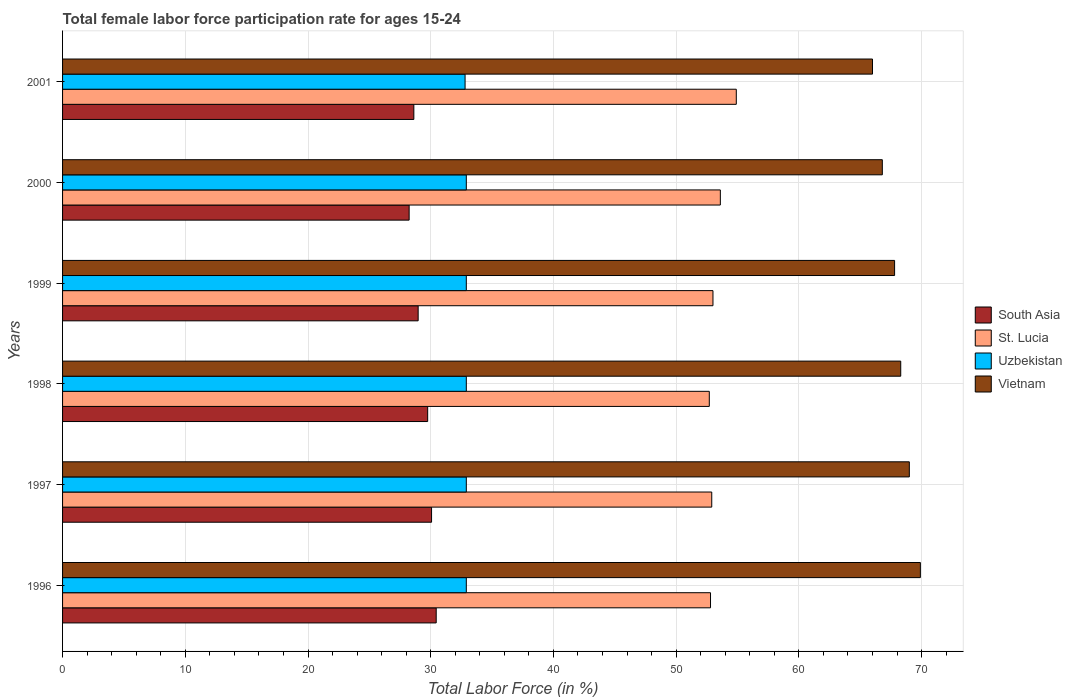How many groups of bars are there?
Provide a short and direct response. 6. How many bars are there on the 6th tick from the top?
Your answer should be compact. 4. What is the female labor force participation rate in South Asia in 1997?
Make the answer very short. 30.07. Across all years, what is the maximum female labor force participation rate in Vietnam?
Make the answer very short. 69.9. Across all years, what is the minimum female labor force participation rate in South Asia?
Your response must be concise. 28.24. In which year was the female labor force participation rate in South Asia maximum?
Make the answer very short. 1996. In which year was the female labor force participation rate in Vietnam minimum?
Your answer should be very brief. 2001. What is the total female labor force participation rate in Vietnam in the graph?
Keep it short and to the point. 407.8. What is the difference between the female labor force participation rate in Vietnam in 1996 and that in 1997?
Your answer should be compact. 0.9. What is the difference between the female labor force participation rate in Vietnam in 2000 and the female labor force participation rate in Uzbekistan in 1997?
Offer a terse response. 33.9. What is the average female labor force participation rate in Uzbekistan per year?
Give a very brief answer. 32.88. In the year 2001, what is the difference between the female labor force participation rate in Uzbekistan and female labor force participation rate in Vietnam?
Your answer should be very brief. -33.2. In how many years, is the female labor force participation rate in Uzbekistan greater than 10 %?
Your answer should be very brief. 6. What is the ratio of the female labor force participation rate in South Asia in 1996 to that in 1998?
Make the answer very short. 1.02. Is the difference between the female labor force participation rate in Uzbekistan in 1998 and 2000 greater than the difference between the female labor force participation rate in Vietnam in 1998 and 2000?
Your answer should be very brief. No. What is the difference between the highest and the second highest female labor force participation rate in South Asia?
Keep it short and to the point. 0.38. What is the difference between the highest and the lowest female labor force participation rate in St. Lucia?
Provide a short and direct response. 2.2. In how many years, is the female labor force participation rate in St. Lucia greater than the average female labor force participation rate in St. Lucia taken over all years?
Your answer should be compact. 2. Is the sum of the female labor force participation rate in Uzbekistan in 1998 and 2001 greater than the maximum female labor force participation rate in St. Lucia across all years?
Provide a succinct answer. Yes. Is it the case that in every year, the sum of the female labor force participation rate in St. Lucia and female labor force participation rate in South Asia is greater than the sum of female labor force participation rate in Vietnam and female labor force participation rate in Uzbekistan?
Make the answer very short. No. Are all the bars in the graph horizontal?
Your response must be concise. Yes. Are the values on the major ticks of X-axis written in scientific E-notation?
Make the answer very short. No. Does the graph contain any zero values?
Provide a short and direct response. No. Where does the legend appear in the graph?
Your response must be concise. Center right. How are the legend labels stacked?
Provide a short and direct response. Vertical. What is the title of the graph?
Offer a terse response. Total female labor force participation rate for ages 15-24. Does "American Samoa" appear as one of the legend labels in the graph?
Your answer should be compact. No. What is the label or title of the Y-axis?
Your response must be concise. Years. What is the Total Labor Force (in %) in South Asia in 1996?
Provide a short and direct response. 30.45. What is the Total Labor Force (in %) in St. Lucia in 1996?
Keep it short and to the point. 52.8. What is the Total Labor Force (in %) in Uzbekistan in 1996?
Your answer should be compact. 32.9. What is the Total Labor Force (in %) in Vietnam in 1996?
Your answer should be very brief. 69.9. What is the Total Labor Force (in %) of South Asia in 1997?
Make the answer very short. 30.07. What is the Total Labor Force (in %) of St. Lucia in 1997?
Give a very brief answer. 52.9. What is the Total Labor Force (in %) of Uzbekistan in 1997?
Ensure brevity in your answer.  32.9. What is the Total Labor Force (in %) of Vietnam in 1997?
Make the answer very short. 69. What is the Total Labor Force (in %) of South Asia in 1998?
Make the answer very short. 29.75. What is the Total Labor Force (in %) in St. Lucia in 1998?
Keep it short and to the point. 52.7. What is the Total Labor Force (in %) of Uzbekistan in 1998?
Offer a very short reply. 32.9. What is the Total Labor Force (in %) in Vietnam in 1998?
Provide a succinct answer. 68.3. What is the Total Labor Force (in %) in South Asia in 1999?
Offer a terse response. 28.98. What is the Total Labor Force (in %) of Uzbekistan in 1999?
Provide a succinct answer. 32.9. What is the Total Labor Force (in %) of Vietnam in 1999?
Offer a terse response. 67.8. What is the Total Labor Force (in %) of South Asia in 2000?
Offer a very short reply. 28.24. What is the Total Labor Force (in %) in St. Lucia in 2000?
Provide a short and direct response. 53.6. What is the Total Labor Force (in %) of Uzbekistan in 2000?
Your answer should be very brief. 32.9. What is the Total Labor Force (in %) in Vietnam in 2000?
Your answer should be very brief. 66.8. What is the Total Labor Force (in %) of South Asia in 2001?
Your answer should be very brief. 28.63. What is the Total Labor Force (in %) of St. Lucia in 2001?
Offer a very short reply. 54.9. What is the Total Labor Force (in %) of Uzbekistan in 2001?
Offer a very short reply. 32.8. Across all years, what is the maximum Total Labor Force (in %) in South Asia?
Your response must be concise. 30.45. Across all years, what is the maximum Total Labor Force (in %) in St. Lucia?
Offer a terse response. 54.9. Across all years, what is the maximum Total Labor Force (in %) of Uzbekistan?
Your answer should be very brief. 32.9. Across all years, what is the maximum Total Labor Force (in %) in Vietnam?
Your response must be concise. 69.9. Across all years, what is the minimum Total Labor Force (in %) in South Asia?
Offer a very short reply. 28.24. Across all years, what is the minimum Total Labor Force (in %) of St. Lucia?
Offer a very short reply. 52.7. Across all years, what is the minimum Total Labor Force (in %) in Uzbekistan?
Provide a short and direct response. 32.8. Across all years, what is the minimum Total Labor Force (in %) of Vietnam?
Provide a succinct answer. 66. What is the total Total Labor Force (in %) in South Asia in the graph?
Your answer should be very brief. 176.11. What is the total Total Labor Force (in %) in St. Lucia in the graph?
Provide a succinct answer. 319.9. What is the total Total Labor Force (in %) in Uzbekistan in the graph?
Provide a short and direct response. 197.3. What is the total Total Labor Force (in %) of Vietnam in the graph?
Give a very brief answer. 407.8. What is the difference between the Total Labor Force (in %) in South Asia in 1996 and that in 1997?
Keep it short and to the point. 0.38. What is the difference between the Total Labor Force (in %) in St. Lucia in 1996 and that in 1997?
Make the answer very short. -0.1. What is the difference between the Total Labor Force (in %) in Vietnam in 1996 and that in 1997?
Provide a short and direct response. 0.9. What is the difference between the Total Labor Force (in %) of South Asia in 1996 and that in 1998?
Ensure brevity in your answer.  0.69. What is the difference between the Total Labor Force (in %) in St. Lucia in 1996 and that in 1998?
Your response must be concise. 0.1. What is the difference between the Total Labor Force (in %) of Uzbekistan in 1996 and that in 1998?
Provide a succinct answer. 0. What is the difference between the Total Labor Force (in %) of Vietnam in 1996 and that in 1998?
Provide a succinct answer. 1.6. What is the difference between the Total Labor Force (in %) in South Asia in 1996 and that in 1999?
Your answer should be very brief. 1.47. What is the difference between the Total Labor Force (in %) in Uzbekistan in 1996 and that in 1999?
Provide a succinct answer. 0. What is the difference between the Total Labor Force (in %) in South Asia in 1996 and that in 2000?
Offer a terse response. 2.2. What is the difference between the Total Labor Force (in %) in Uzbekistan in 1996 and that in 2000?
Make the answer very short. 0. What is the difference between the Total Labor Force (in %) of Vietnam in 1996 and that in 2000?
Provide a short and direct response. 3.1. What is the difference between the Total Labor Force (in %) of South Asia in 1996 and that in 2001?
Give a very brief answer. 1.82. What is the difference between the Total Labor Force (in %) in St. Lucia in 1996 and that in 2001?
Offer a very short reply. -2.1. What is the difference between the Total Labor Force (in %) in Uzbekistan in 1996 and that in 2001?
Keep it short and to the point. 0.1. What is the difference between the Total Labor Force (in %) in Vietnam in 1996 and that in 2001?
Your response must be concise. 3.9. What is the difference between the Total Labor Force (in %) of South Asia in 1997 and that in 1998?
Your answer should be compact. 0.32. What is the difference between the Total Labor Force (in %) in St. Lucia in 1997 and that in 1998?
Your response must be concise. 0.2. What is the difference between the Total Labor Force (in %) in Uzbekistan in 1997 and that in 1998?
Offer a terse response. 0. What is the difference between the Total Labor Force (in %) of South Asia in 1997 and that in 1999?
Offer a very short reply. 1.09. What is the difference between the Total Labor Force (in %) of Uzbekistan in 1997 and that in 1999?
Your answer should be compact. 0. What is the difference between the Total Labor Force (in %) of Vietnam in 1997 and that in 1999?
Your response must be concise. 1.2. What is the difference between the Total Labor Force (in %) in South Asia in 1997 and that in 2000?
Provide a short and direct response. 1.83. What is the difference between the Total Labor Force (in %) in South Asia in 1997 and that in 2001?
Your answer should be compact. 1.44. What is the difference between the Total Labor Force (in %) of St. Lucia in 1997 and that in 2001?
Provide a succinct answer. -2. What is the difference between the Total Labor Force (in %) in Vietnam in 1997 and that in 2001?
Make the answer very short. 3. What is the difference between the Total Labor Force (in %) in South Asia in 1998 and that in 1999?
Ensure brevity in your answer.  0.78. What is the difference between the Total Labor Force (in %) of South Asia in 1998 and that in 2000?
Ensure brevity in your answer.  1.51. What is the difference between the Total Labor Force (in %) in Vietnam in 1998 and that in 2000?
Keep it short and to the point. 1.5. What is the difference between the Total Labor Force (in %) in South Asia in 1998 and that in 2001?
Ensure brevity in your answer.  1.13. What is the difference between the Total Labor Force (in %) of St. Lucia in 1998 and that in 2001?
Your answer should be very brief. -2.2. What is the difference between the Total Labor Force (in %) of Vietnam in 1998 and that in 2001?
Offer a very short reply. 2.3. What is the difference between the Total Labor Force (in %) of South Asia in 1999 and that in 2000?
Ensure brevity in your answer.  0.73. What is the difference between the Total Labor Force (in %) of St. Lucia in 1999 and that in 2000?
Provide a succinct answer. -0.6. What is the difference between the Total Labor Force (in %) of Vietnam in 1999 and that in 2000?
Provide a succinct answer. 1. What is the difference between the Total Labor Force (in %) of South Asia in 1999 and that in 2001?
Your answer should be very brief. 0.35. What is the difference between the Total Labor Force (in %) of St. Lucia in 1999 and that in 2001?
Your answer should be compact. -1.9. What is the difference between the Total Labor Force (in %) in Uzbekistan in 1999 and that in 2001?
Keep it short and to the point. 0.1. What is the difference between the Total Labor Force (in %) in Vietnam in 1999 and that in 2001?
Provide a succinct answer. 1.8. What is the difference between the Total Labor Force (in %) in South Asia in 2000 and that in 2001?
Keep it short and to the point. -0.38. What is the difference between the Total Labor Force (in %) in South Asia in 1996 and the Total Labor Force (in %) in St. Lucia in 1997?
Keep it short and to the point. -22.45. What is the difference between the Total Labor Force (in %) in South Asia in 1996 and the Total Labor Force (in %) in Uzbekistan in 1997?
Provide a succinct answer. -2.45. What is the difference between the Total Labor Force (in %) of South Asia in 1996 and the Total Labor Force (in %) of Vietnam in 1997?
Ensure brevity in your answer.  -38.55. What is the difference between the Total Labor Force (in %) in St. Lucia in 1996 and the Total Labor Force (in %) in Uzbekistan in 1997?
Your answer should be compact. 19.9. What is the difference between the Total Labor Force (in %) in St. Lucia in 1996 and the Total Labor Force (in %) in Vietnam in 1997?
Ensure brevity in your answer.  -16.2. What is the difference between the Total Labor Force (in %) in Uzbekistan in 1996 and the Total Labor Force (in %) in Vietnam in 1997?
Offer a terse response. -36.1. What is the difference between the Total Labor Force (in %) of South Asia in 1996 and the Total Labor Force (in %) of St. Lucia in 1998?
Your answer should be very brief. -22.25. What is the difference between the Total Labor Force (in %) in South Asia in 1996 and the Total Labor Force (in %) in Uzbekistan in 1998?
Ensure brevity in your answer.  -2.45. What is the difference between the Total Labor Force (in %) of South Asia in 1996 and the Total Labor Force (in %) of Vietnam in 1998?
Offer a terse response. -37.85. What is the difference between the Total Labor Force (in %) in St. Lucia in 1996 and the Total Labor Force (in %) in Vietnam in 1998?
Your answer should be very brief. -15.5. What is the difference between the Total Labor Force (in %) of Uzbekistan in 1996 and the Total Labor Force (in %) of Vietnam in 1998?
Ensure brevity in your answer.  -35.4. What is the difference between the Total Labor Force (in %) in South Asia in 1996 and the Total Labor Force (in %) in St. Lucia in 1999?
Ensure brevity in your answer.  -22.55. What is the difference between the Total Labor Force (in %) of South Asia in 1996 and the Total Labor Force (in %) of Uzbekistan in 1999?
Provide a short and direct response. -2.45. What is the difference between the Total Labor Force (in %) of South Asia in 1996 and the Total Labor Force (in %) of Vietnam in 1999?
Provide a succinct answer. -37.35. What is the difference between the Total Labor Force (in %) in St. Lucia in 1996 and the Total Labor Force (in %) in Uzbekistan in 1999?
Your answer should be compact. 19.9. What is the difference between the Total Labor Force (in %) of St. Lucia in 1996 and the Total Labor Force (in %) of Vietnam in 1999?
Provide a short and direct response. -15. What is the difference between the Total Labor Force (in %) in Uzbekistan in 1996 and the Total Labor Force (in %) in Vietnam in 1999?
Make the answer very short. -34.9. What is the difference between the Total Labor Force (in %) in South Asia in 1996 and the Total Labor Force (in %) in St. Lucia in 2000?
Provide a short and direct response. -23.15. What is the difference between the Total Labor Force (in %) of South Asia in 1996 and the Total Labor Force (in %) of Uzbekistan in 2000?
Make the answer very short. -2.45. What is the difference between the Total Labor Force (in %) of South Asia in 1996 and the Total Labor Force (in %) of Vietnam in 2000?
Provide a succinct answer. -36.35. What is the difference between the Total Labor Force (in %) in St. Lucia in 1996 and the Total Labor Force (in %) in Uzbekistan in 2000?
Ensure brevity in your answer.  19.9. What is the difference between the Total Labor Force (in %) of Uzbekistan in 1996 and the Total Labor Force (in %) of Vietnam in 2000?
Your answer should be very brief. -33.9. What is the difference between the Total Labor Force (in %) in South Asia in 1996 and the Total Labor Force (in %) in St. Lucia in 2001?
Offer a very short reply. -24.45. What is the difference between the Total Labor Force (in %) in South Asia in 1996 and the Total Labor Force (in %) in Uzbekistan in 2001?
Ensure brevity in your answer.  -2.35. What is the difference between the Total Labor Force (in %) of South Asia in 1996 and the Total Labor Force (in %) of Vietnam in 2001?
Offer a terse response. -35.55. What is the difference between the Total Labor Force (in %) of St. Lucia in 1996 and the Total Labor Force (in %) of Uzbekistan in 2001?
Give a very brief answer. 20. What is the difference between the Total Labor Force (in %) in St. Lucia in 1996 and the Total Labor Force (in %) in Vietnam in 2001?
Provide a succinct answer. -13.2. What is the difference between the Total Labor Force (in %) of Uzbekistan in 1996 and the Total Labor Force (in %) of Vietnam in 2001?
Offer a terse response. -33.1. What is the difference between the Total Labor Force (in %) of South Asia in 1997 and the Total Labor Force (in %) of St. Lucia in 1998?
Offer a very short reply. -22.63. What is the difference between the Total Labor Force (in %) in South Asia in 1997 and the Total Labor Force (in %) in Uzbekistan in 1998?
Provide a short and direct response. -2.83. What is the difference between the Total Labor Force (in %) of South Asia in 1997 and the Total Labor Force (in %) of Vietnam in 1998?
Offer a very short reply. -38.23. What is the difference between the Total Labor Force (in %) of St. Lucia in 1997 and the Total Labor Force (in %) of Uzbekistan in 1998?
Offer a terse response. 20. What is the difference between the Total Labor Force (in %) in St. Lucia in 1997 and the Total Labor Force (in %) in Vietnam in 1998?
Keep it short and to the point. -15.4. What is the difference between the Total Labor Force (in %) of Uzbekistan in 1997 and the Total Labor Force (in %) of Vietnam in 1998?
Provide a short and direct response. -35.4. What is the difference between the Total Labor Force (in %) of South Asia in 1997 and the Total Labor Force (in %) of St. Lucia in 1999?
Offer a very short reply. -22.93. What is the difference between the Total Labor Force (in %) of South Asia in 1997 and the Total Labor Force (in %) of Uzbekistan in 1999?
Your response must be concise. -2.83. What is the difference between the Total Labor Force (in %) of South Asia in 1997 and the Total Labor Force (in %) of Vietnam in 1999?
Offer a terse response. -37.73. What is the difference between the Total Labor Force (in %) of St. Lucia in 1997 and the Total Labor Force (in %) of Vietnam in 1999?
Offer a very short reply. -14.9. What is the difference between the Total Labor Force (in %) of Uzbekistan in 1997 and the Total Labor Force (in %) of Vietnam in 1999?
Give a very brief answer. -34.9. What is the difference between the Total Labor Force (in %) in South Asia in 1997 and the Total Labor Force (in %) in St. Lucia in 2000?
Make the answer very short. -23.53. What is the difference between the Total Labor Force (in %) in South Asia in 1997 and the Total Labor Force (in %) in Uzbekistan in 2000?
Offer a very short reply. -2.83. What is the difference between the Total Labor Force (in %) of South Asia in 1997 and the Total Labor Force (in %) of Vietnam in 2000?
Keep it short and to the point. -36.73. What is the difference between the Total Labor Force (in %) of St. Lucia in 1997 and the Total Labor Force (in %) of Uzbekistan in 2000?
Your response must be concise. 20. What is the difference between the Total Labor Force (in %) in Uzbekistan in 1997 and the Total Labor Force (in %) in Vietnam in 2000?
Offer a terse response. -33.9. What is the difference between the Total Labor Force (in %) of South Asia in 1997 and the Total Labor Force (in %) of St. Lucia in 2001?
Offer a terse response. -24.83. What is the difference between the Total Labor Force (in %) in South Asia in 1997 and the Total Labor Force (in %) in Uzbekistan in 2001?
Your answer should be compact. -2.73. What is the difference between the Total Labor Force (in %) in South Asia in 1997 and the Total Labor Force (in %) in Vietnam in 2001?
Keep it short and to the point. -35.93. What is the difference between the Total Labor Force (in %) in St. Lucia in 1997 and the Total Labor Force (in %) in Uzbekistan in 2001?
Your answer should be compact. 20.1. What is the difference between the Total Labor Force (in %) in St. Lucia in 1997 and the Total Labor Force (in %) in Vietnam in 2001?
Your answer should be very brief. -13.1. What is the difference between the Total Labor Force (in %) in Uzbekistan in 1997 and the Total Labor Force (in %) in Vietnam in 2001?
Give a very brief answer. -33.1. What is the difference between the Total Labor Force (in %) in South Asia in 1998 and the Total Labor Force (in %) in St. Lucia in 1999?
Make the answer very short. -23.25. What is the difference between the Total Labor Force (in %) in South Asia in 1998 and the Total Labor Force (in %) in Uzbekistan in 1999?
Offer a terse response. -3.15. What is the difference between the Total Labor Force (in %) of South Asia in 1998 and the Total Labor Force (in %) of Vietnam in 1999?
Give a very brief answer. -38.05. What is the difference between the Total Labor Force (in %) of St. Lucia in 1998 and the Total Labor Force (in %) of Uzbekistan in 1999?
Your answer should be very brief. 19.8. What is the difference between the Total Labor Force (in %) in St. Lucia in 1998 and the Total Labor Force (in %) in Vietnam in 1999?
Offer a terse response. -15.1. What is the difference between the Total Labor Force (in %) of Uzbekistan in 1998 and the Total Labor Force (in %) of Vietnam in 1999?
Make the answer very short. -34.9. What is the difference between the Total Labor Force (in %) in South Asia in 1998 and the Total Labor Force (in %) in St. Lucia in 2000?
Provide a short and direct response. -23.85. What is the difference between the Total Labor Force (in %) of South Asia in 1998 and the Total Labor Force (in %) of Uzbekistan in 2000?
Offer a terse response. -3.15. What is the difference between the Total Labor Force (in %) of South Asia in 1998 and the Total Labor Force (in %) of Vietnam in 2000?
Your answer should be compact. -37.05. What is the difference between the Total Labor Force (in %) in St. Lucia in 1998 and the Total Labor Force (in %) in Uzbekistan in 2000?
Make the answer very short. 19.8. What is the difference between the Total Labor Force (in %) of St. Lucia in 1998 and the Total Labor Force (in %) of Vietnam in 2000?
Your response must be concise. -14.1. What is the difference between the Total Labor Force (in %) in Uzbekistan in 1998 and the Total Labor Force (in %) in Vietnam in 2000?
Your answer should be very brief. -33.9. What is the difference between the Total Labor Force (in %) in South Asia in 1998 and the Total Labor Force (in %) in St. Lucia in 2001?
Provide a succinct answer. -25.15. What is the difference between the Total Labor Force (in %) of South Asia in 1998 and the Total Labor Force (in %) of Uzbekistan in 2001?
Your answer should be very brief. -3.05. What is the difference between the Total Labor Force (in %) in South Asia in 1998 and the Total Labor Force (in %) in Vietnam in 2001?
Your response must be concise. -36.25. What is the difference between the Total Labor Force (in %) of St. Lucia in 1998 and the Total Labor Force (in %) of Uzbekistan in 2001?
Your response must be concise. 19.9. What is the difference between the Total Labor Force (in %) of St. Lucia in 1998 and the Total Labor Force (in %) of Vietnam in 2001?
Provide a succinct answer. -13.3. What is the difference between the Total Labor Force (in %) of Uzbekistan in 1998 and the Total Labor Force (in %) of Vietnam in 2001?
Your answer should be very brief. -33.1. What is the difference between the Total Labor Force (in %) of South Asia in 1999 and the Total Labor Force (in %) of St. Lucia in 2000?
Offer a very short reply. -24.62. What is the difference between the Total Labor Force (in %) of South Asia in 1999 and the Total Labor Force (in %) of Uzbekistan in 2000?
Provide a succinct answer. -3.92. What is the difference between the Total Labor Force (in %) of South Asia in 1999 and the Total Labor Force (in %) of Vietnam in 2000?
Offer a terse response. -37.82. What is the difference between the Total Labor Force (in %) in St. Lucia in 1999 and the Total Labor Force (in %) in Uzbekistan in 2000?
Ensure brevity in your answer.  20.1. What is the difference between the Total Labor Force (in %) of St. Lucia in 1999 and the Total Labor Force (in %) of Vietnam in 2000?
Make the answer very short. -13.8. What is the difference between the Total Labor Force (in %) of Uzbekistan in 1999 and the Total Labor Force (in %) of Vietnam in 2000?
Your response must be concise. -33.9. What is the difference between the Total Labor Force (in %) in South Asia in 1999 and the Total Labor Force (in %) in St. Lucia in 2001?
Your answer should be very brief. -25.92. What is the difference between the Total Labor Force (in %) in South Asia in 1999 and the Total Labor Force (in %) in Uzbekistan in 2001?
Your answer should be very brief. -3.82. What is the difference between the Total Labor Force (in %) in South Asia in 1999 and the Total Labor Force (in %) in Vietnam in 2001?
Keep it short and to the point. -37.02. What is the difference between the Total Labor Force (in %) of St. Lucia in 1999 and the Total Labor Force (in %) of Uzbekistan in 2001?
Offer a terse response. 20.2. What is the difference between the Total Labor Force (in %) of Uzbekistan in 1999 and the Total Labor Force (in %) of Vietnam in 2001?
Make the answer very short. -33.1. What is the difference between the Total Labor Force (in %) of South Asia in 2000 and the Total Labor Force (in %) of St. Lucia in 2001?
Offer a terse response. -26.66. What is the difference between the Total Labor Force (in %) in South Asia in 2000 and the Total Labor Force (in %) in Uzbekistan in 2001?
Keep it short and to the point. -4.56. What is the difference between the Total Labor Force (in %) of South Asia in 2000 and the Total Labor Force (in %) of Vietnam in 2001?
Offer a very short reply. -37.76. What is the difference between the Total Labor Force (in %) of St. Lucia in 2000 and the Total Labor Force (in %) of Uzbekistan in 2001?
Ensure brevity in your answer.  20.8. What is the difference between the Total Labor Force (in %) of Uzbekistan in 2000 and the Total Labor Force (in %) of Vietnam in 2001?
Your answer should be very brief. -33.1. What is the average Total Labor Force (in %) in South Asia per year?
Offer a terse response. 29.35. What is the average Total Labor Force (in %) of St. Lucia per year?
Offer a terse response. 53.32. What is the average Total Labor Force (in %) of Uzbekistan per year?
Your answer should be compact. 32.88. What is the average Total Labor Force (in %) in Vietnam per year?
Your response must be concise. 67.97. In the year 1996, what is the difference between the Total Labor Force (in %) of South Asia and Total Labor Force (in %) of St. Lucia?
Keep it short and to the point. -22.35. In the year 1996, what is the difference between the Total Labor Force (in %) in South Asia and Total Labor Force (in %) in Uzbekistan?
Your response must be concise. -2.45. In the year 1996, what is the difference between the Total Labor Force (in %) of South Asia and Total Labor Force (in %) of Vietnam?
Provide a succinct answer. -39.45. In the year 1996, what is the difference between the Total Labor Force (in %) in St. Lucia and Total Labor Force (in %) in Uzbekistan?
Offer a very short reply. 19.9. In the year 1996, what is the difference between the Total Labor Force (in %) of St. Lucia and Total Labor Force (in %) of Vietnam?
Ensure brevity in your answer.  -17.1. In the year 1996, what is the difference between the Total Labor Force (in %) of Uzbekistan and Total Labor Force (in %) of Vietnam?
Keep it short and to the point. -37. In the year 1997, what is the difference between the Total Labor Force (in %) in South Asia and Total Labor Force (in %) in St. Lucia?
Offer a very short reply. -22.83. In the year 1997, what is the difference between the Total Labor Force (in %) in South Asia and Total Labor Force (in %) in Uzbekistan?
Your answer should be compact. -2.83. In the year 1997, what is the difference between the Total Labor Force (in %) of South Asia and Total Labor Force (in %) of Vietnam?
Give a very brief answer. -38.93. In the year 1997, what is the difference between the Total Labor Force (in %) of St. Lucia and Total Labor Force (in %) of Uzbekistan?
Your answer should be very brief. 20. In the year 1997, what is the difference between the Total Labor Force (in %) in St. Lucia and Total Labor Force (in %) in Vietnam?
Your answer should be compact. -16.1. In the year 1997, what is the difference between the Total Labor Force (in %) of Uzbekistan and Total Labor Force (in %) of Vietnam?
Your answer should be very brief. -36.1. In the year 1998, what is the difference between the Total Labor Force (in %) of South Asia and Total Labor Force (in %) of St. Lucia?
Your response must be concise. -22.95. In the year 1998, what is the difference between the Total Labor Force (in %) in South Asia and Total Labor Force (in %) in Uzbekistan?
Your answer should be compact. -3.15. In the year 1998, what is the difference between the Total Labor Force (in %) of South Asia and Total Labor Force (in %) of Vietnam?
Provide a short and direct response. -38.55. In the year 1998, what is the difference between the Total Labor Force (in %) of St. Lucia and Total Labor Force (in %) of Uzbekistan?
Your answer should be compact. 19.8. In the year 1998, what is the difference between the Total Labor Force (in %) in St. Lucia and Total Labor Force (in %) in Vietnam?
Offer a terse response. -15.6. In the year 1998, what is the difference between the Total Labor Force (in %) of Uzbekistan and Total Labor Force (in %) of Vietnam?
Provide a succinct answer. -35.4. In the year 1999, what is the difference between the Total Labor Force (in %) in South Asia and Total Labor Force (in %) in St. Lucia?
Offer a terse response. -24.02. In the year 1999, what is the difference between the Total Labor Force (in %) in South Asia and Total Labor Force (in %) in Uzbekistan?
Ensure brevity in your answer.  -3.92. In the year 1999, what is the difference between the Total Labor Force (in %) in South Asia and Total Labor Force (in %) in Vietnam?
Provide a succinct answer. -38.82. In the year 1999, what is the difference between the Total Labor Force (in %) of St. Lucia and Total Labor Force (in %) of Uzbekistan?
Your answer should be compact. 20.1. In the year 1999, what is the difference between the Total Labor Force (in %) of St. Lucia and Total Labor Force (in %) of Vietnam?
Keep it short and to the point. -14.8. In the year 1999, what is the difference between the Total Labor Force (in %) in Uzbekistan and Total Labor Force (in %) in Vietnam?
Offer a very short reply. -34.9. In the year 2000, what is the difference between the Total Labor Force (in %) of South Asia and Total Labor Force (in %) of St. Lucia?
Offer a terse response. -25.36. In the year 2000, what is the difference between the Total Labor Force (in %) of South Asia and Total Labor Force (in %) of Uzbekistan?
Provide a short and direct response. -4.66. In the year 2000, what is the difference between the Total Labor Force (in %) of South Asia and Total Labor Force (in %) of Vietnam?
Make the answer very short. -38.56. In the year 2000, what is the difference between the Total Labor Force (in %) of St. Lucia and Total Labor Force (in %) of Uzbekistan?
Give a very brief answer. 20.7. In the year 2000, what is the difference between the Total Labor Force (in %) in St. Lucia and Total Labor Force (in %) in Vietnam?
Offer a very short reply. -13.2. In the year 2000, what is the difference between the Total Labor Force (in %) in Uzbekistan and Total Labor Force (in %) in Vietnam?
Provide a succinct answer. -33.9. In the year 2001, what is the difference between the Total Labor Force (in %) of South Asia and Total Labor Force (in %) of St. Lucia?
Ensure brevity in your answer.  -26.27. In the year 2001, what is the difference between the Total Labor Force (in %) of South Asia and Total Labor Force (in %) of Uzbekistan?
Provide a succinct answer. -4.17. In the year 2001, what is the difference between the Total Labor Force (in %) in South Asia and Total Labor Force (in %) in Vietnam?
Your response must be concise. -37.37. In the year 2001, what is the difference between the Total Labor Force (in %) of St. Lucia and Total Labor Force (in %) of Uzbekistan?
Provide a short and direct response. 22.1. In the year 2001, what is the difference between the Total Labor Force (in %) of Uzbekistan and Total Labor Force (in %) of Vietnam?
Ensure brevity in your answer.  -33.2. What is the ratio of the Total Labor Force (in %) in South Asia in 1996 to that in 1997?
Give a very brief answer. 1.01. What is the ratio of the Total Labor Force (in %) in Vietnam in 1996 to that in 1997?
Offer a very short reply. 1.01. What is the ratio of the Total Labor Force (in %) of South Asia in 1996 to that in 1998?
Your answer should be very brief. 1.02. What is the ratio of the Total Labor Force (in %) of St. Lucia in 1996 to that in 1998?
Keep it short and to the point. 1. What is the ratio of the Total Labor Force (in %) in Uzbekistan in 1996 to that in 1998?
Offer a terse response. 1. What is the ratio of the Total Labor Force (in %) in Vietnam in 1996 to that in 1998?
Make the answer very short. 1.02. What is the ratio of the Total Labor Force (in %) in South Asia in 1996 to that in 1999?
Ensure brevity in your answer.  1.05. What is the ratio of the Total Labor Force (in %) in St. Lucia in 1996 to that in 1999?
Give a very brief answer. 1. What is the ratio of the Total Labor Force (in %) of Vietnam in 1996 to that in 1999?
Provide a succinct answer. 1.03. What is the ratio of the Total Labor Force (in %) in South Asia in 1996 to that in 2000?
Provide a succinct answer. 1.08. What is the ratio of the Total Labor Force (in %) of St. Lucia in 1996 to that in 2000?
Provide a succinct answer. 0.99. What is the ratio of the Total Labor Force (in %) of Vietnam in 1996 to that in 2000?
Give a very brief answer. 1.05. What is the ratio of the Total Labor Force (in %) of South Asia in 1996 to that in 2001?
Provide a succinct answer. 1.06. What is the ratio of the Total Labor Force (in %) in St. Lucia in 1996 to that in 2001?
Provide a succinct answer. 0.96. What is the ratio of the Total Labor Force (in %) of Vietnam in 1996 to that in 2001?
Give a very brief answer. 1.06. What is the ratio of the Total Labor Force (in %) in South Asia in 1997 to that in 1998?
Offer a terse response. 1.01. What is the ratio of the Total Labor Force (in %) of St. Lucia in 1997 to that in 1998?
Give a very brief answer. 1. What is the ratio of the Total Labor Force (in %) of Uzbekistan in 1997 to that in 1998?
Provide a short and direct response. 1. What is the ratio of the Total Labor Force (in %) of Vietnam in 1997 to that in 1998?
Ensure brevity in your answer.  1.01. What is the ratio of the Total Labor Force (in %) of South Asia in 1997 to that in 1999?
Make the answer very short. 1.04. What is the ratio of the Total Labor Force (in %) of St. Lucia in 1997 to that in 1999?
Your answer should be very brief. 1. What is the ratio of the Total Labor Force (in %) of Vietnam in 1997 to that in 1999?
Make the answer very short. 1.02. What is the ratio of the Total Labor Force (in %) of South Asia in 1997 to that in 2000?
Ensure brevity in your answer.  1.06. What is the ratio of the Total Labor Force (in %) in St. Lucia in 1997 to that in 2000?
Your response must be concise. 0.99. What is the ratio of the Total Labor Force (in %) in Vietnam in 1997 to that in 2000?
Provide a succinct answer. 1.03. What is the ratio of the Total Labor Force (in %) of South Asia in 1997 to that in 2001?
Make the answer very short. 1.05. What is the ratio of the Total Labor Force (in %) of St. Lucia in 1997 to that in 2001?
Make the answer very short. 0.96. What is the ratio of the Total Labor Force (in %) of Uzbekistan in 1997 to that in 2001?
Offer a terse response. 1. What is the ratio of the Total Labor Force (in %) of Vietnam in 1997 to that in 2001?
Provide a short and direct response. 1.05. What is the ratio of the Total Labor Force (in %) in South Asia in 1998 to that in 1999?
Offer a terse response. 1.03. What is the ratio of the Total Labor Force (in %) in St. Lucia in 1998 to that in 1999?
Give a very brief answer. 0.99. What is the ratio of the Total Labor Force (in %) of Vietnam in 1998 to that in 1999?
Provide a succinct answer. 1.01. What is the ratio of the Total Labor Force (in %) in South Asia in 1998 to that in 2000?
Offer a terse response. 1.05. What is the ratio of the Total Labor Force (in %) in St. Lucia in 1998 to that in 2000?
Make the answer very short. 0.98. What is the ratio of the Total Labor Force (in %) in Vietnam in 1998 to that in 2000?
Keep it short and to the point. 1.02. What is the ratio of the Total Labor Force (in %) in South Asia in 1998 to that in 2001?
Make the answer very short. 1.04. What is the ratio of the Total Labor Force (in %) in St. Lucia in 1998 to that in 2001?
Your response must be concise. 0.96. What is the ratio of the Total Labor Force (in %) of Vietnam in 1998 to that in 2001?
Provide a short and direct response. 1.03. What is the ratio of the Total Labor Force (in %) in Vietnam in 1999 to that in 2000?
Give a very brief answer. 1.01. What is the ratio of the Total Labor Force (in %) of South Asia in 1999 to that in 2001?
Keep it short and to the point. 1.01. What is the ratio of the Total Labor Force (in %) in St. Lucia in 1999 to that in 2001?
Offer a very short reply. 0.97. What is the ratio of the Total Labor Force (in %) in Uzbekistan in 1999 to that in 2001?
Your response must be concise. 1. What is the ratio of the Total Labor Force (in %) of Vietnam in 1999 to that in 2001?
Provide a succinct answer. 1.03. What is the ratio of the Total Labor Force (in %) of South Asia in 2000 to that in 2001?
Keep it short and to the point. 0.99. What is the ratio of the Total Labor Force (in %) of St. Lucia in 2000 to that in 2001?
Your answer should be compact. 0.98. What is the ratio of the Total Labor Force (in %) in Uzbekistan in 2000 to that in 2001?
Offer a very short reply. 1. What is the ratio of the Total Labor Force (in %) of Vietnam in 2000 to that in 2001?
Your response must be concise. 1.01. What is the difference between the highest and the second highest Total Labor Force (in %) of South Asia?
Provide a succinct answer. 0.38. What is the difference between the highest and the second highest Total Labor Force (in %) in Uzbekistan?
Your answer should be very brief. 0. What is the difference between the highest and the lowest Total Labor Force (in %) in South Asia?
Keep it short and to the point. 2.2. What is the difference between the highest and the lowest Total Labor Force (in %) in St. Lucia?
Ensure brevity in your answer.  2.2. What is the difference between the highest and the lowest Total Labor Force (in %) of Uzbekistan?
Give a very brief answer. 0.1. 